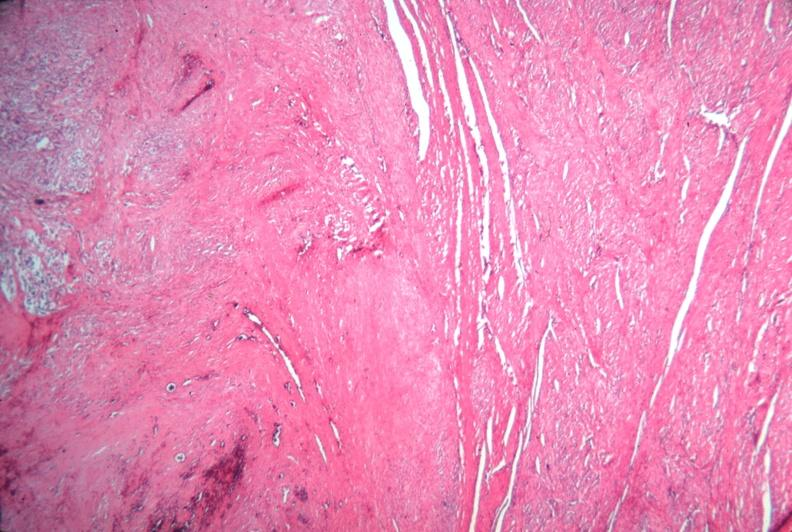s bicornate uterus present?
Answer the question using a single word or phrase. No 